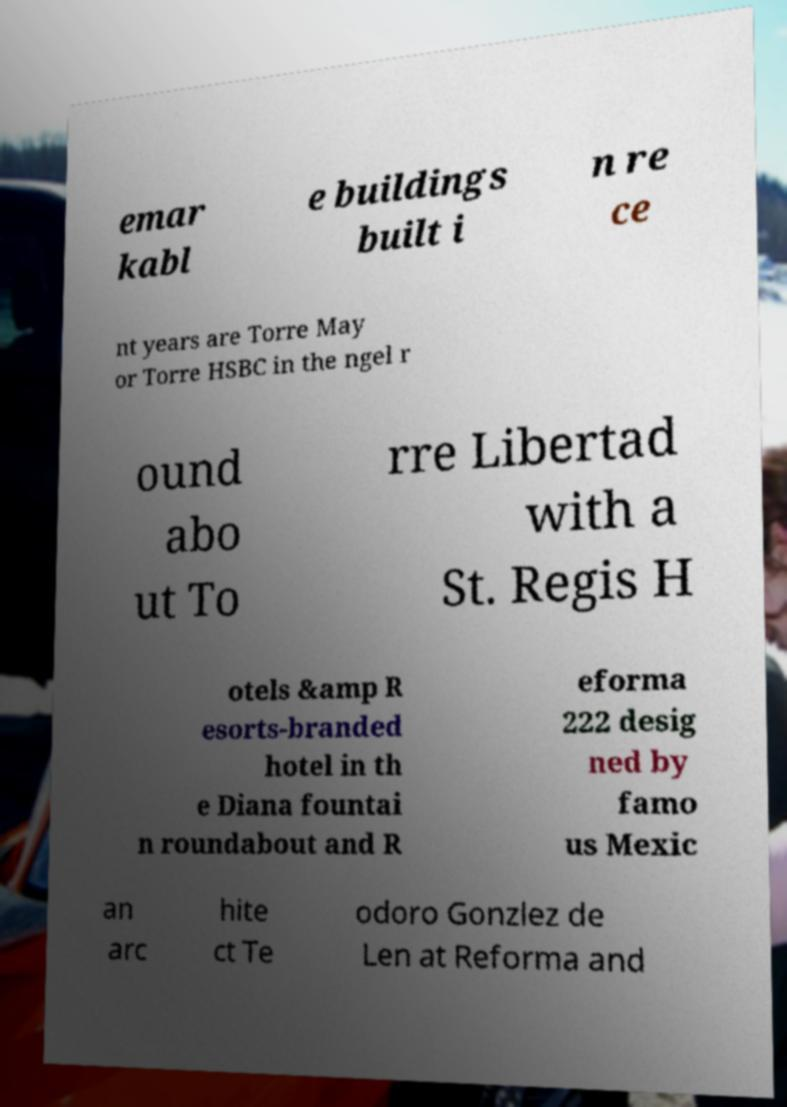Could you extract and type out the text from this image? emar kabl e buildings built i n re ce nt years are Torre May or Torre HSBC in the ngel r ound abo ut To rre Libertad with a St. Regis H otels &amp R esorts-branded hotel in th e Diana fountai n roundabout and R eforma 222 desig ned by famo us Mexic an arc hite ct Te odoro Gonzlez de Len at Reforma and 